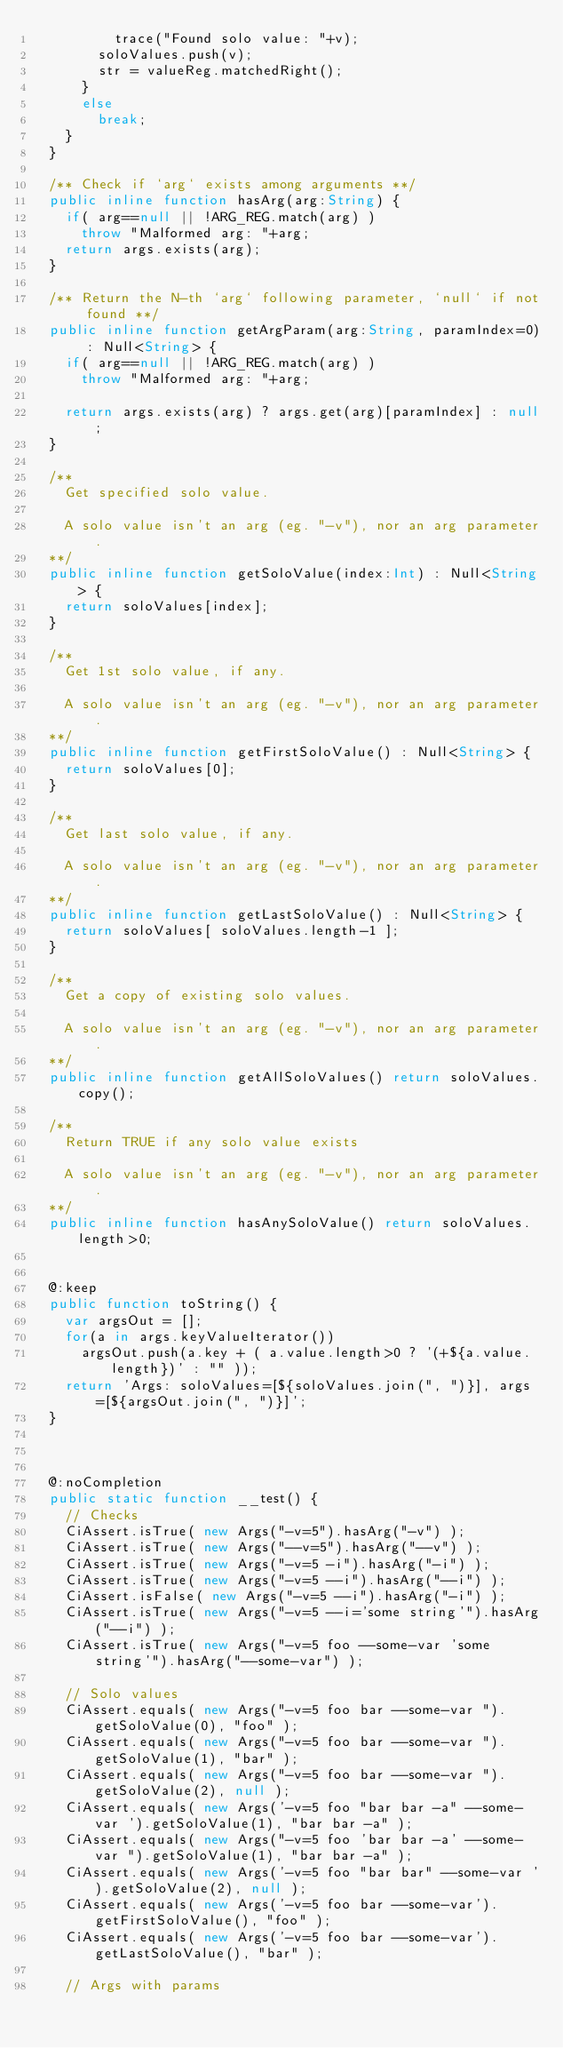Convert code to text. <code><loc_0><loc_0><loc_500><loc_500><_Haxe_>					trace("Found solo value: "+v);
				soloValues.push(v);
				str = valueReg.matchedRight();
			}
			else
				break;
		}
	}

	/** Check if `arg` exists among arguments **/
	public inline function hasArg(arg:String) {
		if( arg==null || !ARG_REG.match(arg) )
			throw "Malformed arg: "+arg;
		return args.exists(arg);
	}

	/** Return the N-th `arg` following parameter, `null` if not found **/
	public inline function getArgParam(arg:String, paramIndex=0) : Null<String> {
		if( arg==null || !ARG_REG.match(arg) )
			throw "Malformed arg: "+arg;

		return args.exists(arg) ? args.get(arg)[paramIndex] : null;
	}

	/**
		Get specified solo value.

		A solo value isn't an arg (eg. "-v"), nor an arg parameter.
	**/
	public inline function getSoloValue(index:Int) : Null<String> {
		return soloValues[index];
	}

	/**
		Get 1st solo value, if any.

		A solo value isn't an arg (eg. "-v"), nor an arg parameter.
	**/
	public inline function getFirstSoloValue() : Null<String> {
		return soloValues[0];
	}

	/**
		Get last solo value, if any.

		A solo value isn't an arg (eg. "-v"), nor an arg parameter.
	**/
	public inline function getLastSoloValue() : Null<String> {
		return soloValues[ soloValues.length-1 ];
	}

	/**
		Get a copy of existing solo values.

		A solo value isn't an arg (eg. "-v"), nor an arg parameter.
	**/
	public inline function getAllSoloValues() return soloValues.copy();

	/**
		Return TRUE if any solo value exists

		A solo value isn't an arg (eg. "-v"), nor an arg parameter.
	**/
	public inline function hasAnySoloValue() return soloValues.length>0;


	@:keep
	public function toString() {
		var argsOut = [];
		for(a in args.keyValueIterator())
			argsOut.push(a.key + ( a.value.length>0 ? '(+${a.value.length})' : "" ));
		return 'Args: soloValues=[${soloValues.join(", ")}], args=[${argsOut.join(", ")}]';
	}



	@:noCompletion
	public static function __test() {
		// Checks
		CiAssert.isTrue( new Args("-v=5").hasArg("-v") );
		CiAssert.isTrue( new Args("--v=5").hasArg("--v") );
		CiAssert.isTrue( new Args("-v=5 -i").hasArg("-i") );
		CiAssert.isTrue( new Args("-v=5 --i").hasArg("--i") );
		CiAssert.isFalse( new Args("-v=5 --i").hasArg("-i") );
		CiAssert.isTrue( new Args("-v=5 --i='some string'").hasArg("--i") );
		CiAssert.isTrue( new Args("-v=5 foo --some-var 'some string'").hasArg("--some-var") );

		// Solo values
		CiAssert.equals( new Args("-v=5 foo bar --some-var ").getSoloValue(0), "foo" );
		CiAssert.equals( new Args("-v=5 foo bar --some-var ").getSoloValue(1), "bar" );
		CiAssert.equals( new Args("-v=5 foo bar --some-var ").getSoloValue(2), null );
		CiAssert.equals( new Args('-v=5 foo "bar bar -a" --some-var ').getSoloValue(1), "bar bar -a" );
		CiAssert.equals( new Args("-v=5 foo 'bar bar -a' --some-var ").getSoloValue(1), "bar bar -a" );
		CiAssert.equals( new Args('-v=5 foo "bar bar" --some-var ').getSoloValue(2), null );
		CiAssert.equals( new Args('-v=5 foo bar --some-var').getFirstSoloValue(), "foo" );
		CiAssert.equals( new Args('-v=5 foo bar --some-var').getLastSoloValue(), "bar" );

		// Args with params</code> 